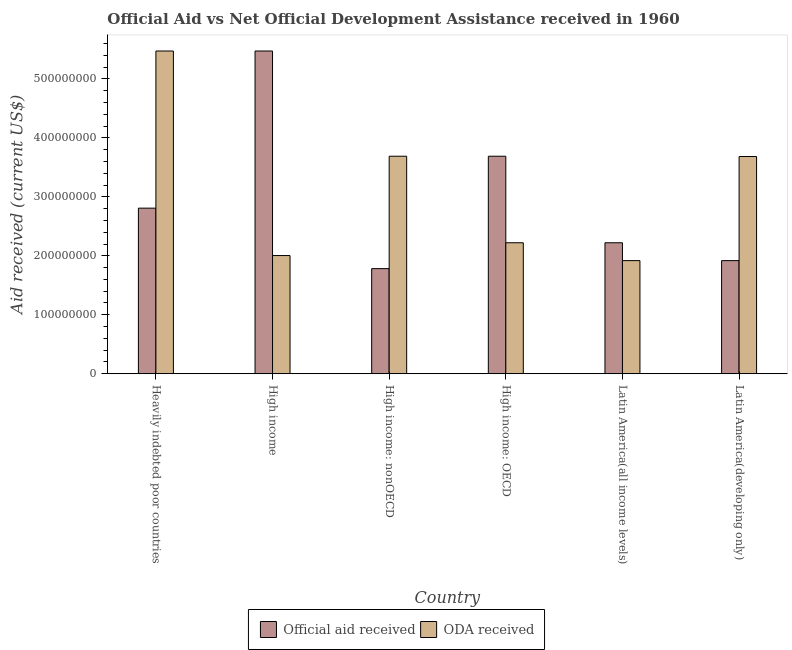How many different coloured bars are there?
Your answer should be compact. 2. Are the number of bars on each tick of the X-axis equal?
Give a very brief answer. Yes. How many bars are there on the 2nd tick from the left?
Your answer should be compact. 2. How many bars are there on the 3rd tick from the right?
Offer a very short reply. 2. What is the label of the 6th group of bars from the left?
Keep it short and to the point. Latin America(developing only). What is the oda received in Latin America(all income levels)?
Give a very brief answer. 1.92e+08. Across all countries, what is the maximum official aid received?
Your response must be concise. 5.47e+08. Across all countries, what is the minimum oda received?
Offer a terse response. 1.92e+08. In which country was the oda received maximum?
Offer a terse response. Heavily indebted poor countries. In which country was the oda received minimum?
Your response must be concise. Latin America(all income levels). What is the total oda received in the graph?
Make the answer very short. 1.90e+09. What is the difference between the official aid received in High income: OECD and that in Latin America(all income levels)?
Offer a terse response. 1.47e+08. What is the difference between the oda received in High income: OECD and the official aid received in High income: nonOECD?
Provide a succinct answer. 4.39e+07. What is the average oda received per country?
Offer a terse response. 3.17e+08. What is the difference between the official aid received and oda received in Latin America(all income levels)?
Offer a terse response. 3.03e+07. What is the ratio of the official aid received in Heavily indebted poor countries to that in High income: OECD?
Keep it short and to the point. 0.76. Is the difference between the official aid received in High income and Latin America(all income levels) greater than the difference between the oda received in High income and Latin America(all income levels)?
Offer a terse response. Yes. What is the difference between the highest and the second highest official aid received?
Your response must be concise. 1.78e+08. What is the difference between the highest and the lowest oda received?
Provide a succinct answer. 3.56e+08. In how many countries, is the oda received greater than the average oda received taken over all countries?
Offer a terse response. 3. What does the 2nd bar from the left in Heavily indebted poor countries represents?
Keep it short and to the point. ODA received. What does the 1st bar from the right in Heavily indebted poor countries represents?
Offer a very short reply. ODA received. Are all the bars in the graph horizontal?
Ensure brevity in your answer.  No. How many countries are there in the graph?
Keep it short and to the point. 6. Where does the legend appear in the graph?
Make the answer very short. Bottom center. How many legend labels are there?
Give a very brief answer. 2. How are the legend labels stacked?
Provide a succinct answer. Horizontal. What is the title of the graph?
Your answer should be very brief. Official Aid vs Net Official Development Assistance received in 1960 . Does "Public funds" appear as one of the legend labels in the graph?
Provide a short and direct response. No. What is the label or title of the X-axis?
Provide a short and direct response. Country. What is the label or title of the Y-axis?
Provide a succinct answer. Aid received (current US$). What is the Aid received (current US$) of Official aid received in Heavily indebted poor countries?
Keep it short and to the point. 2.81e+08. What is the Aid received (current US$) in ODA received in Heavily indebted poor countries?
Provide a short and direct response. 5.47e+08. What is the Aid received (current US$) in Official aid received in High income?
Your answer should be compact. 5.47e+08. What is the Aid received (current US$) in ODA received in High income?
Your answer should be compact. 2.00e+08. What is the Aid received (current US$) of Official aid received in High income: nonOECD?
Offer a terse response. 1.78e+08. What is the Aid received (current US$) in ODA received in High income: nonOECD?
Make the answer very short. 3.69e+08. What is the Aid received (current US$) of Official aid received in High income: OECD?
Ensure brevity in your answer.  3.69e+08. What is the Aid received (current US$) in ODA received in High income: OECD?
Your answer should be compact. 2.22e+08. What is the Aid received (current US$) in Official aid received in Latin America(all income levels)?
Your answer should be compact. 2.22e+08. What is the Aid received (current US$) in ODA received in Latin America(all income levels)?
Your response must be concise. 1.92e+08. What is the Aid received (current US$) in Official aid received in Latin America(developing only)?
Make the answer very short. 1.92e+08. What is the Aid received (current US$) of ODA received in Latin America(developing only)?
Make the answer very short. 3.68e+08. Across all countries, what is the maximum Aid received (current US$) in Official aid received?
Your answer should be compact. 5.47e+08. Across all countries, what is the maximum Aid received (current US$) in ODA received?
Ensure brevity in your answer.  5.47e+08. Across all countries, what is the minimum Aid received (current US$) in Official aid received?
Your answer should be very brief. 1.78e+08. Across all countries, what is the minimum Aid received (current US$) in ODA received?
Provide a short and direct response. 1.92e+08. What is the total Aid received (current US$) of Official aid received in the graph?
Your response must be concise. 1.79e+09. What is the total Aid received (current US$) of ODA received in the graph?
Your answer should be compact. 1.90e+09. What is the difference between the Aid received (current US$) in Official aid received in Heavily indebted poor countries and that in High income?
Give a very brief answer. -2.67e+08. What is the difference between the Aid received (current US$) of ODA received in Heavily indebted poor countries and that in High income?
Provide a short and direct response. 3.47e+08. What is the difference between the Aid received (current US$) in Official aid received in Heavily indebted poor countries and that in High income: nonOECD?
Give a very brief answer. 1.03e+08. What is the difference between the Aid received (current US$) of ODA received in Heavily indebted poor countries and that in High income: nonOECD?
Provide a succinct answer. 1.78e+08. What is the difference between the Aid received (current US$) in Official aid received in Heavily indebted poor countries and that in High income: OECD?
Your response must be concise. -8.81e+07. What is the difference between the Aid received (current US$) in ODA received in Heavily indebted poor countries and that in High income: OECD?
Provide a short and direct response. 3.25e+08. What is the difference between the Aid received (current US$) in Official aid received in Heavily indebted poor countries and that in Latin America(all income levels)?
Your answer should be compact. 5.87e+07. What is the difference between the Aid received (current US$) of ODA received in Heavily indebted poor countries and that in Latin America(all income levels)?
Your answer should be very brief. 3.56e+08. What is the difference between the Aid received (current US$) of Official aid received in Heavily indebted poor countries and that in Latin America(developing only)?
Make the answer very short. 8.90e+07. What is the difference between the Aid received (current US$) of ODA received in Heavily indebted poor countries and that in Latin America(developing only)?
Give a very brief answer. 1.79e+08. What is the difference between the Aid received (current US$) of Official aid received in High income and that in High income: nonOECD?
Your response must be concise. 3.69e+08. What is the difference between the Aid received (current US$) of ODA received in High income and that in High income: nonOECD?
Offer a terse response. -1.68e+08. What is the difference between the Aid received (current US$) of Official aid received in High income and that in High income: OECD?
Your response must be concise. 1.78e+08. What is the difference between the Aid received (current US$) of ODA received in High income and that in High income: OECD?
Your answer should be compact. -2.17e+07. What is the difference between the Aid received (current US$) of Official aid received in High income and that in Latin America(all income levels)?
Provide a succinct answer. 3.25e+08. What is the difference between the Aid received (current US$) in ODA received in High income and that in Latin America(all income levels)?
Provide a short and direct response. 8.59e+06. What is the difference between the Aid received (current US$) in Official aid received in High income and that in Latin America(developing only)?
Give a very brief answer. 3.56e+08. What is the difference between the Aid received (current US$) of ODA received in High income and that in Latin America(developing only)?
Offer a terse response. -1.68e+08. What is the difference between the Aid received (current US$) of Official aid received in High income: nonOECD and that in High income: OECD?
Offer a terse response. -1.91e+08. What is the difference between the Aid received (current US$) of ODA received in High income: nonOECD and that in High income: OECD?
Your response must be concise. 1.47e+08. What is the difference between the Aid received (current US$) in Official aid received in High income: nonOECD and that in Latin America(all income levels)?
Provide a short and direct response. -4.39e+07. What is the difference between the Aid received (current US$) in ODA received in High income: nonOECD and that in Latin America(all income levels)?
Ensure brevity in your answer.  1.77e+08. What is the difference between the Aid received (current US$) in Official aid received in High income: nonOECD and that in Latin America(developing only)?
Your answer should be compact. -1.36e+07. What is the difference between the Aid received (current US$) of ODA received in High income: nonOECD and that in Latin America(developing only)?
Keep it short and to the point. 5.10e+05. What is the difference between the Aid received (current US$) in Official aid received in High income: OECD and that in Latin America(all income levels)?
Provide a short and direct response. 1.47e+08. What is the difference between the Aid received (current US$) in ODA received in High income: OECD and that in Latin America(all income levels)?
Offer a very short reply. 3.03e+07. What is the difference between the Aid received (current US$) in Official aid received in High income: OECD and that in Latin America(developing only)?
Provide a short and direct response. 1.77e+08. What is the difference between the Aid received (current US$) of ODA received in High income: OECD and that in Latin America(developing only)?
Offer a very short reply. -1.46e+08. What is the difference between the Aid received (current US$) in Official aid received in Latin America(all income levels) and that in Latin America(developing only)?
Offer a very short reply. 3.03e+07. What is the difference between the Aid received (current US$) in ODA received in Latin America(all income levels) and that in Latin America(developing only)?
Give a very brief answer. -1.77e+08. What is the difference between the Aid received (current US$) in Official aid received in Heavily indebted poor countries and the Aid received (current US$) in ODA received in High income?
Ensure brevity in your answer.  8.04e+07. What is the difference between the Aid received (current US$) of Official aid received in Heavily indebted poor countries and the Aid received (current US$) of ODA received in High income: nonOECD?
Provide a short and direct response. -8.81e+07. What is the difference between the Aid received (current US$) in Official aid received in Heavily indebted poor countries and the Aid received (current US$) in ODA received in High income: OECD?
Offer a terse response. 5.87e+07. What is the difference between the Aid received (current US$) in Official aid received in Heavily indebted poor countries and the Aid received (current US$) in ODA received in Latin America(all income levels)?
Make the answer very short. 8.90e+07. What is the difference between the Aid received (current US$) of Official aid received in Heavily indebted poor countries and the Aid received (current US$) of ODA received in Latin America(developing only)?
Your answer should be very brief. -8.76e+07. What is the difference between the Aid received (current US$) of Official aid received in High income and the Aid received (current US$) of ODA received in High income: nonOECD?
Make the answer very short. 1.78e+08. What is the difference between the Aid received (current US$) of Official aid received in High income and the Aid received (current US$) of ODA received in High income: OECD?
Make the answer very short. 3.25e+08. What is the difference between the Aid received (current US$) of Official aid received in High income and the Aid received (current US$) of ODA received in Latin America(all income levels)?
Provide a succinct answer. 3.56e+08. What is the difference between the Aid received (current US$) in Official aid received in High income and the Aid received (current US$) in ODA received in Latin America(developing only)?
Your answer should be very brief. 1.79e+08. What is the difference between the Aid received (current US$) in Official aid received in High income: nonOECD and the Aid received (current US$) in ODA received in High income: OECD?
Provide a succinct answer. -4.39e+07. What is the difference between the Aid received (current US$) in Official aid received in High income: nonOECD and the Aid received (current US$) in ODA received in Latin America(all income levels)?
Give a very brief answer. -1.36e+07. What is the difference between the Aid received (current US$) in Official aid received in High income: nonOECD and the Aid received (current US$) in ODA received in Latin America(developing only)?
Provide a succinct answer. -1.90e+08. What is the difference between the Aid received (current US$) of Official aid received in High income: OECD and the Aid received (current US$) of ODA received in Latin America(all income levels)?
Provide a short and direct response. 1.77e+08. What is the difference between the Aid received (current US$) of Official aid received in High income: OECD and the Aid received (current US$) of ODA received in Latin America(developing only)?
Keep it short and to the point. 5.10e+05. What is the difference between the Aid received (current US$) in Official aid received in Latin America(all income levels) and the Aid received (current US$) in ODA received in Latin America(developing only)?
Make the answer very short. -1.46e+08. What is the average Aid received (current US$) of Official aid received per country?
Your response must be concise. 2.98e+08. What is the average Aid received (current US$) in ODA received per country?
Offer a terse response. 3.17e+08. What is the difference between the Aid received (current US$) in Official aid received and Aid received (current US$) in ODA received in Heavily indebted poor countries?
Ensure brevity in your answer.  -2.67e+08. What is the difference between the Aid received (current US$) of Official aid received and Aid received (current US$) of ODA received in High income?
Your answer should be very brief. 3.47e+08. What is the difference between the Aid received (current US$) in Official aid received and Aid received (current US$) in ODA received in High income: nonOECD?
Give a very brief answer. -1.91e+08. What is the difference between the Aid received (current US$) of Official aid received and Aid received (current US$) of ODA received in High income: OECD?
Offer a terse response. 1.47e+08. What is the difference between the Aid received (current US$) in Official aid received and Aid received (current US$) in ODA received in Latin America(all income levels)?
Offer a terse response. 3.03e+07. What is the difference between the Aid received (current US$) in Official aid received and Aid received (current US$) in ODA received in Latin America(developing only)?
Ensure brevity in your answer.  -1.77e+08. What is the ratio of the Aid received (current US$) of Official aid received in Heavily indebted poor countries to that in High income?
Provide a succinct answer. 0.51. What is the ratio of the Aid received (current US$) of ODA received in Heavily indebted poor countries to that in High income?
Offer a terse response. 2.73. What is the ratio of the Aid received (current US$) in Official aid received in Heavily indebted poor countries to that in High income: nonOECD?
Provide a succinct answer. 1.58. What is the ratio of the Aid received (current US$) of ODA received in Heavily indebted poor countries to that in High income: nonOECD?
Give a very brief answer. 1.48. What is the ratio of the Aid received (current US$) of Official aid received in Heavily indebted poor countries to that in High income: OECD?
Provide a short and direct response. 0.76. What is the ratio of the Aid received (current US$) in ODA received in Heavily indebted poor countries to that in High income: OECD?
Offer a very short reply. 2.46. What is the ratio of the Aid received (current US$) in Official aid received in Heavily indebted poor countries to that in Latin America(all income levels)?
Provide a short and direct response. 1.26. What is the ratio of the Aid received (current US$) in ODA received in Heavily indebted poor countries to that in Latin America(all income levels)?
Offer a terse response. 2.85. What is the ratio of the Aid received (current US$) in Official aid received in Heavily indebted poor countries to that in Latin America(developing only)?
Your answer should be very brief. 1.46. What is the ratio of the Aid received (current US$) in ODA received in Heavily indebted poor countries to that in Latin America(developing only)?
Keep it short and to the point. 1.49. What is the ratio of the Aid received (current US$) of Official aid received in High income to that in High income: nonOECD?
Give a very brief answer. 3.07. What is the ratio of the Aid received (current US$) of ODA received in High income to that in High income: nonOECD?
Provide a succinct answer. 0.54. What is the ratio of the Aid received (current US$) in Official aid received in High income to that in High income: OECD?
Offer a very short reply. 1.48. What is the ratio of the Aid received (current US$) of ODA received in High income to that in High income: OECD?
Your answer should be compact. 0.9. What is the ratio of the Aid received (current US$) in Official aid received in High income to that in Latin America(all income levels)?
Make the answer very short. 2.46. What is the ratio of the Aid received (current US$) of ODA received in High income to that in Latin America(all income levels)?
Make the answer very short. 1.04. What is the ratio of the Aid received (current US$) in Official aid received in High income to that in Latin America(developing only)?
Give a very brief answer. 2.85. What is the ratio of the Aid received (current US$) of ODA received in High income to that in Latin America(developing only)?
Your answer should be compact. 0.54. What is the ratio of the Aid received (current US$) of Official aid received in High income: nonOECD to that in High income: OECD?
Offer a very short reply. 0.48. What is the ratio of the Aid received (current US$) in ODA received in High income: nonOECD to that in High income: OECD?
Make the answer very short. 1.66. What is the ratio of the Aid received (current US$) of Official aid received in High income: nonOECD to that in Latin America(all income levels)?
Offer a terse response. 0.8. What is the ratio of the Aid received (current US$) in ODA received in High income: nonOECD to that in Latin America(all income levels)?
Make the answer very short. 1.92. What is the ratio of the Aid received (current US$) in Official aid received in High income: nonOECD to that in Latin America(developing only)?
Offer a terse response. 0.93. What is the ratio of the Aid received (current US$) in Official aid received in High income: OECD to that in Latin America(all income levels)?
Your answer should be very brief. 1.66. What is the ratio of the Aid received (current US$) of ODA received in High income: OECD to that in Latin America(all income levels)?
Your answer should be very brief. 1.16. What is the ratio of the Aid received (current US$) of Official aid received in High income: OECD to that in Latin America(developing only)?
Give a very brief answer. 1.92. What is the ratio of the Aid received (current US$) of ODA received in High income: OECD to that in Latin America(developing only)?
Your answer should be very brief. 0.6. What is the ratio of the Aid received (current US$) of Official aid received in Latin America(all income levels) to that in Latin America(developing only)?
Your answer should be very brief. 1.16. What is the ratio of the Aid received (current US$) in ODA received in Latin America(all income levels) to that in Latin America(developing only)?
Make the answer very short. 0.52. What is the difference between the highest and the second highest Aid received (current US$) of Official aid received?
Keep it short and to the point. 1.78e+08. What is the difference between the highest and the second highest Aid received (current US$) of ODA received?
Your answer should be compact. 1.78e+08. What is the difference between the highest and the lowest Aid received (current US$) in Official aid received?
Your answer should be very brief. 3.69e+08. What is the difference between the highest and the lowest Aid received (current US$) in ODA received?
Offer a terse response. 3.56e+08. 